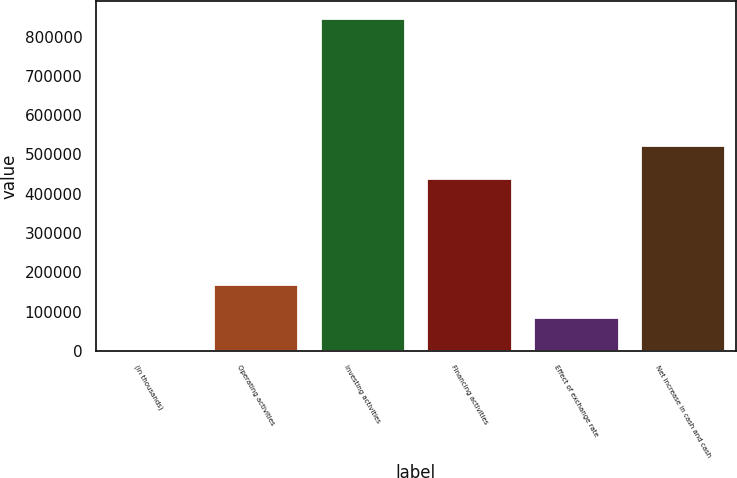Convert chart to OTSL. <chart><loc_0><loc_0><loc_500><loc_500><bar_chart><fcel>(In thousands)<fcel>Operating activities<fcel>Investing activities<fcel>Financing activities<fcel>Effect of exchange rate<fcel>Net increase in cash and cash<nl><fcel>2015<fcel>171107<fcel>847475<fcel>440078<fcel>86561<fcel>524624<nl></chart> 